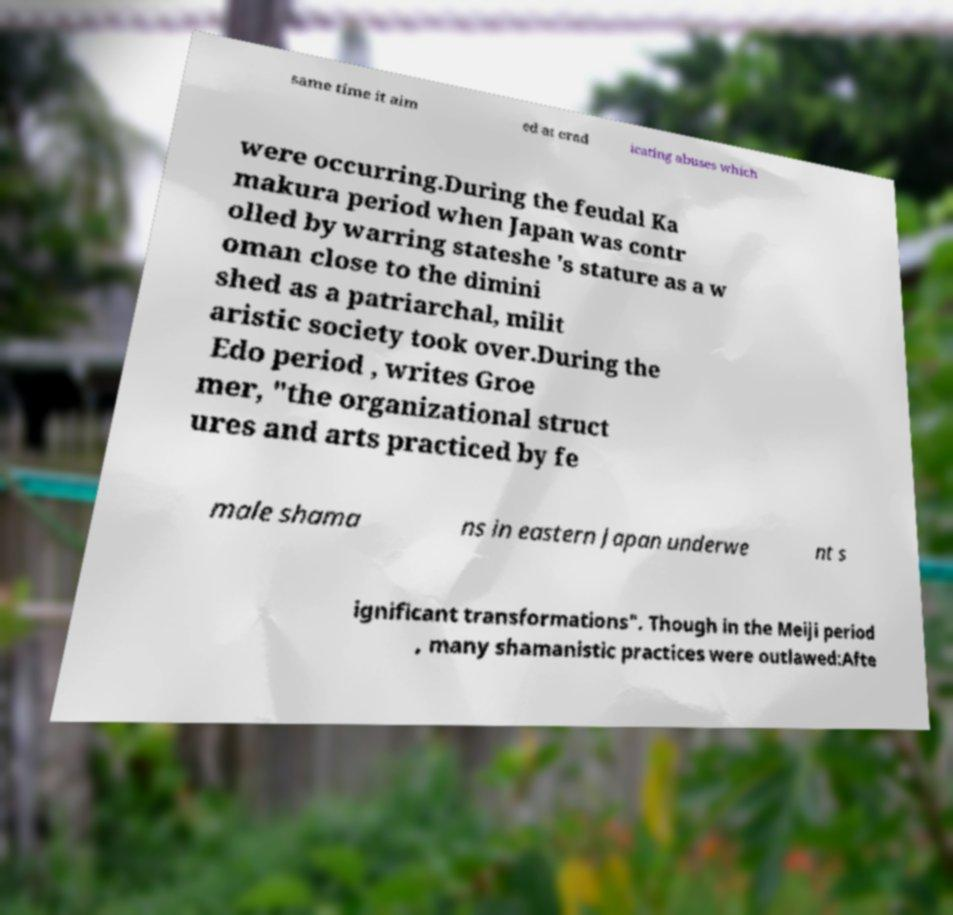Please identify and transcribe the text found in this image. same time it aim ed at erad icating abuses which were occurring.During the feudal Ka makura period when Japan was contr olled by warring stateshe 's stature as a w oman close to the dimini shed as a patriarchal, milit aristic society took over.During the Edo period , writes Groe mer, "the organizational struct ures and arts practiced by fe male shama ns in eastern Japan underwe nt s ignificant transformations". Though in the Meiji period , many shamanistic practices were outlawed:Afte 